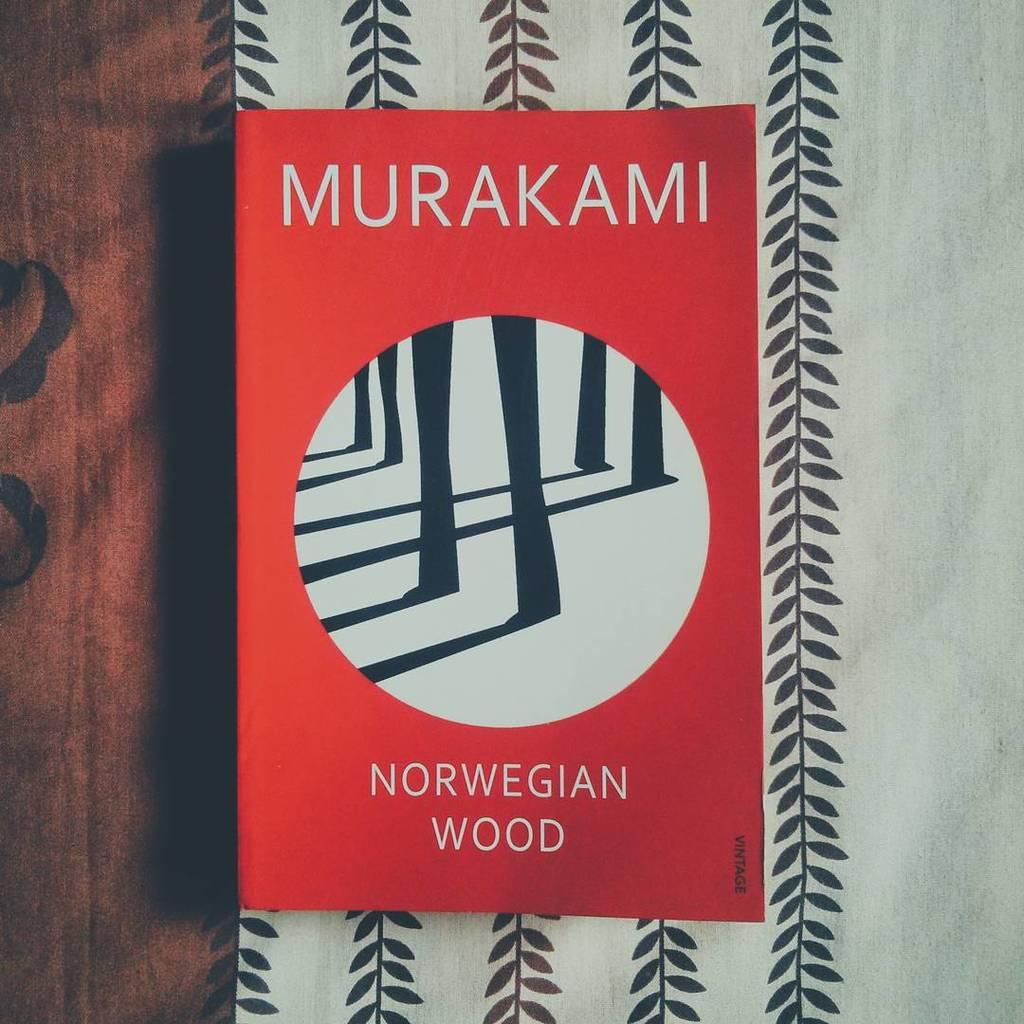<image>
Create a compact narrative representing the image presented. A red label that states that the wood is Norwegian. 